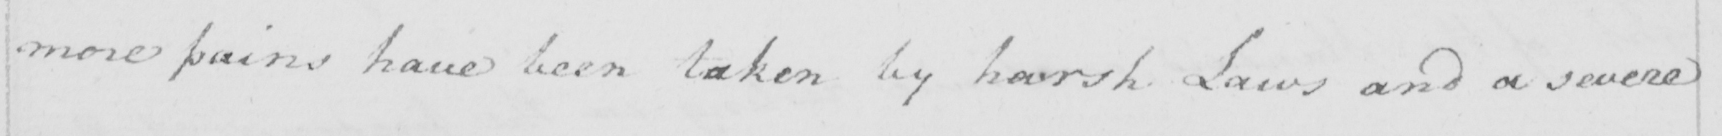What does this handwritten line say? more pains have been taken by harsh Laws and a severe 